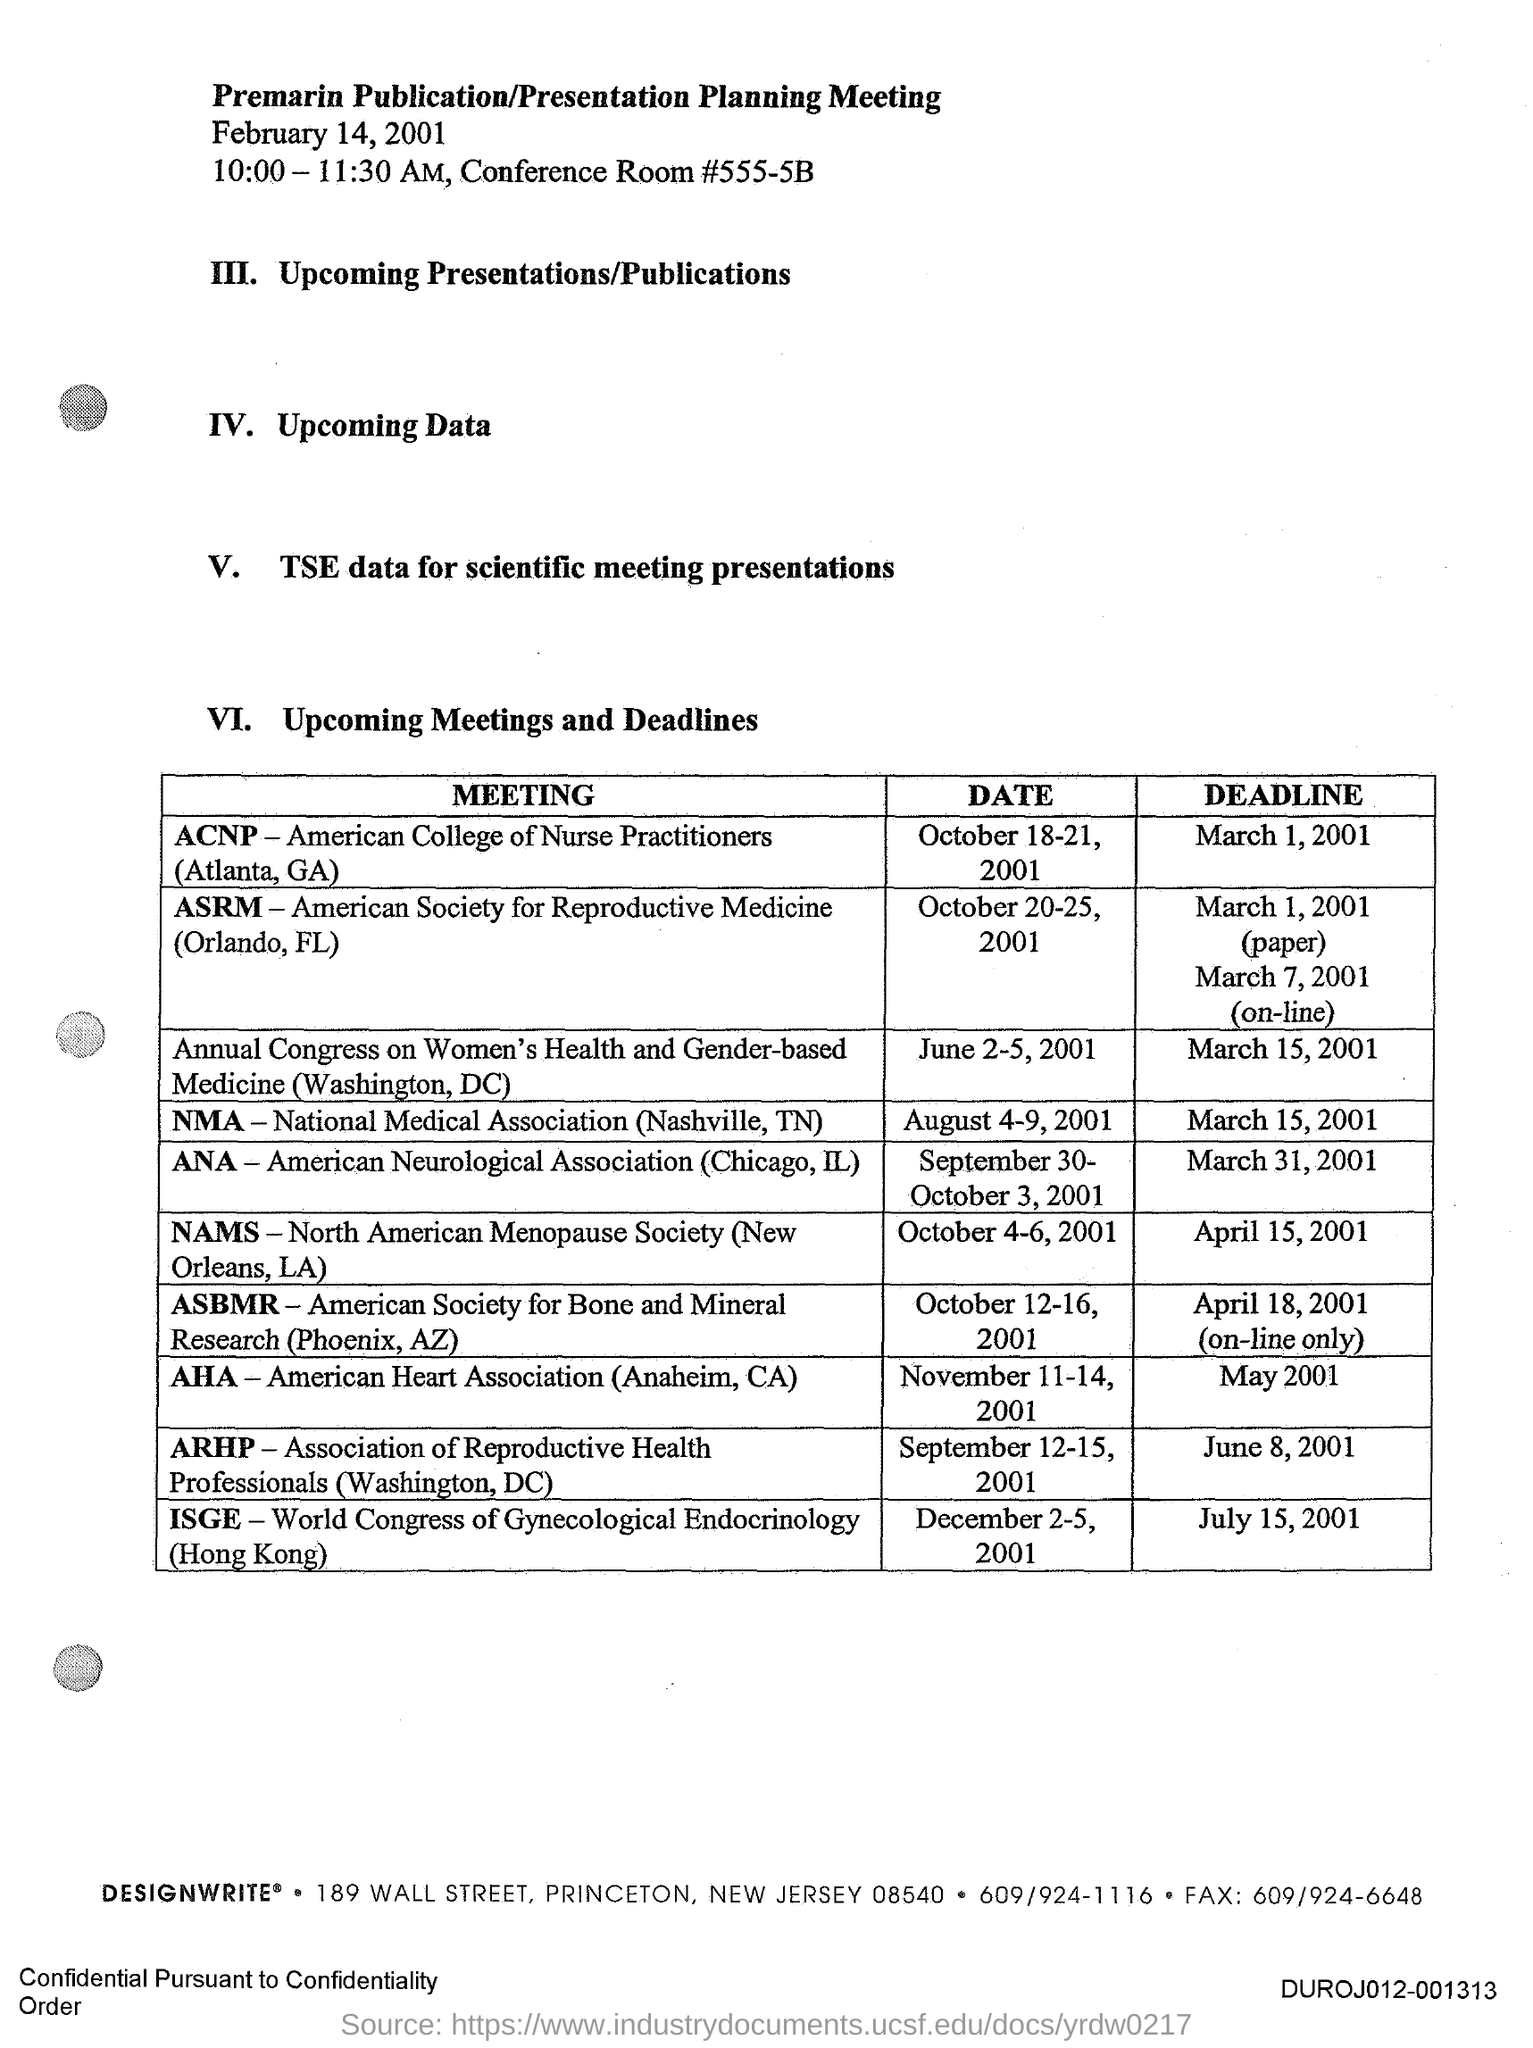What date is the Premarin Publication/Presentation Planning Meeting held?
Offer a terse response. February 14, 2001. What time is the Premarin Publication/Presentation Planning Meeting scheduled on February 14, 2001?
Provide a succinct answer. 10:00- 11:30 AM. What is the meeting date of ACNP (Atlanta, GA)?
Make the answer very short. OCTOBER 18-21, 2001. What is the fullform of NMA?
Offer a terse response. National Medical Association. What is the fullform of AHA?
Provide a short and direct response. AMERICAN HEART ASSOCIATION. What is the deadline of AHA (Anaheim, CA) meeting?
Provide a succinct answer. MAY 2001. What is the deadline of ISGE (Hongkong) meeting?
Offer a terse response. JULY 15, 2001. What is the meeting date of ANA (Chicago, IL)?
Provide a short and direct response. SEPTEMBER 30- OCTOBER 3, 2001. What is the fullform of ANA?
Your answer should be compact. American Neurological Association. 